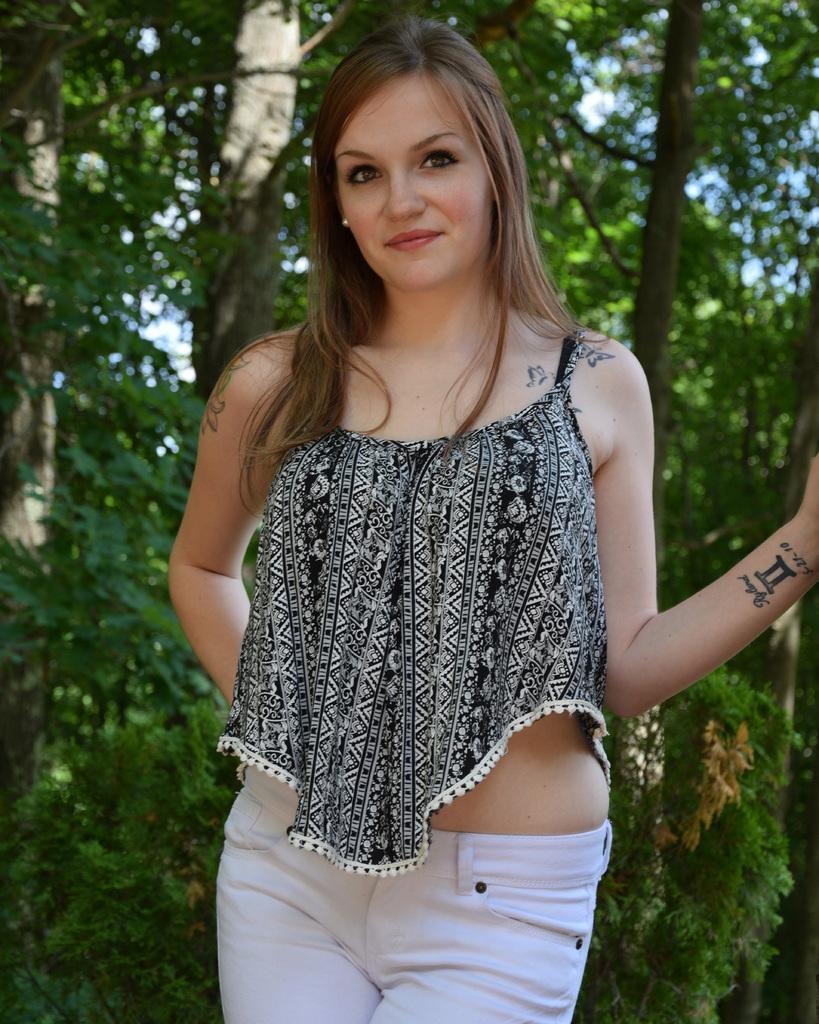Could you give a brief overview of what you see in this image? In the image there is a woman, she is standing and posing for the photo and behind the woman there are trees. 